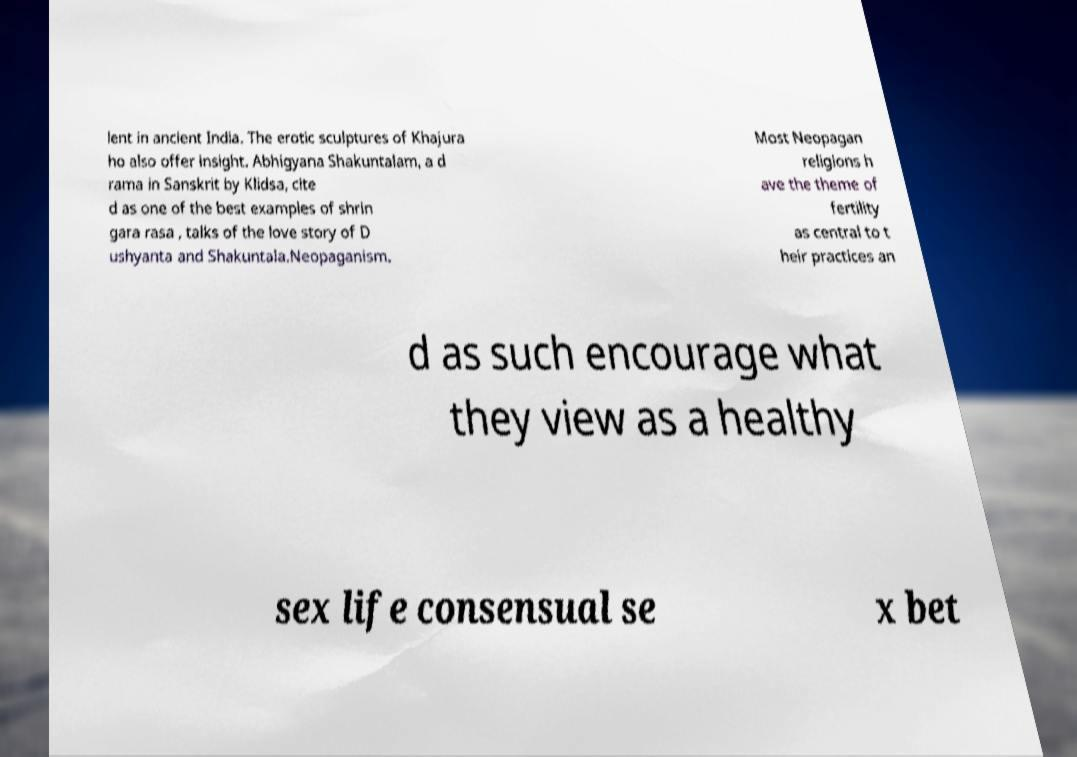There's text embedded in this image that I need extracted. Can you transcribe it verbatim? lent in ancient India. The erotic sculptures of Khajura ho also offer insight. Abhigyana Shakuntalam, a d rama in Sanskrit by Klidsa, cite d as one of the best examples of shrin gara rasa , talks of the love story of D ushyanta and Shakuntala.Neopaganism. Most Neopagan religions h ave the theme of fertility as central to t heir practices an d as such encourage what they view as a healthy sex life consensual se x bet 